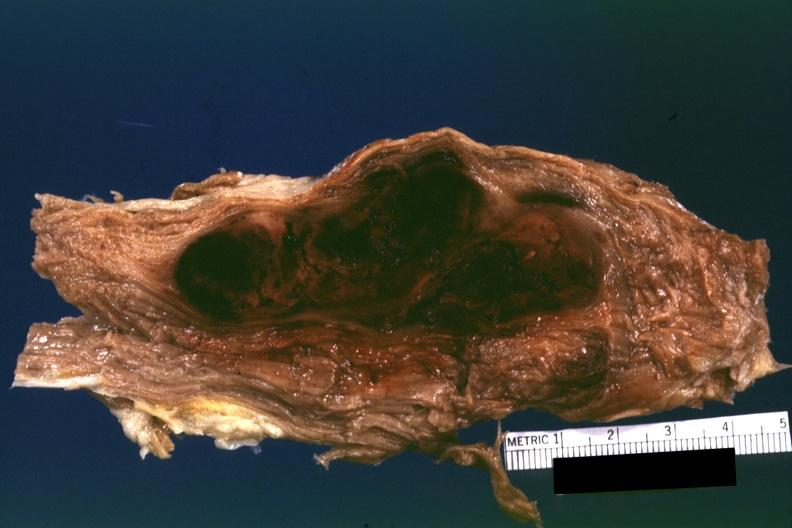s this what this appears to be in a psoas muscle if so the diagnosis on all other slides of this case in this file needs to be changed?
Answer the question using a single word or phrase. Yes 